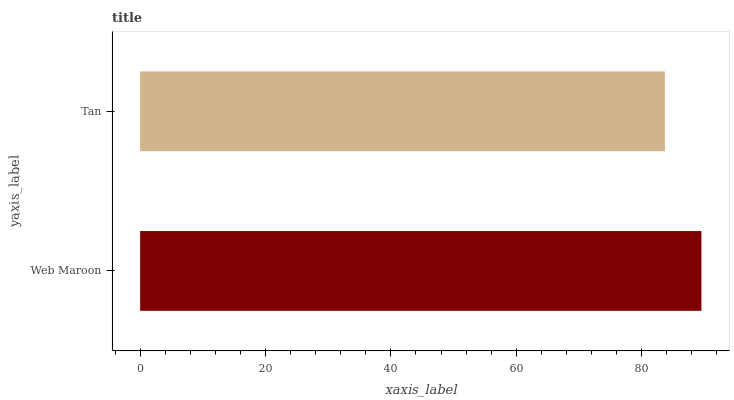Is Tan the minimum?
Answer yes or no. Yes. Is Web Maroon the maximum?
Answer yes or no. Yes. Is Tan the maximum?
Answer yes or no. No. Is Web Maroon greater than Tan?
Answer yes or no. Yes. Is Tan less than Web Maroon?
Answer yes or no. Yes. Is Tan greater than Web Maroon?
Answer yes or no. No. Is Web Maroon less than Tan?
Answer yes or no. No. Is Web Maroon the high median?
Answer yes or no. Yes. Is Tan the low median?
Answer yes or no. Yes. Is Tan the high median?
Answer yes or no. No. Is Web Maroon the low median?
Answer yes or no. No. 